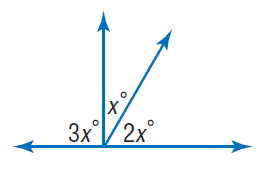Answer the mathemtical geometry problem and directly provide the correct option letter.
Question: Find x.
Choices: A: 30 B: 60 C: 90 D: 180 A 